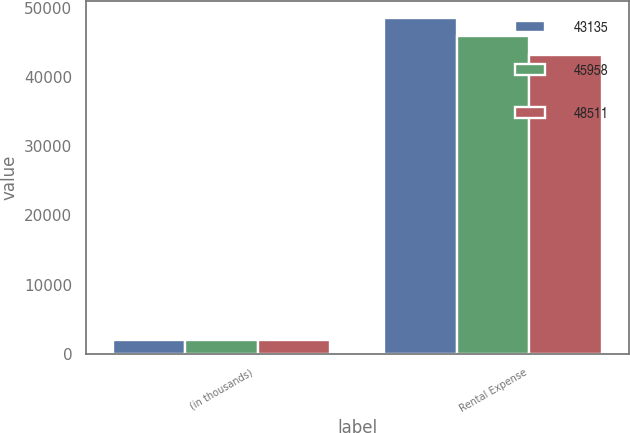Convert chart to OTSL. <chart><loc_0><loc_0><loc_500><loc_500><stacked_bar_chart><ecel><fcel>(in thousands)<fcel>Rental Expense<nl><fcel>43135<fcel>2012<fcel>48511<nl><fcel>45958<fcel>2011<fcel>45958<nl><fcel>48511<fcel>2010<fcel>43135<nl></chart> 